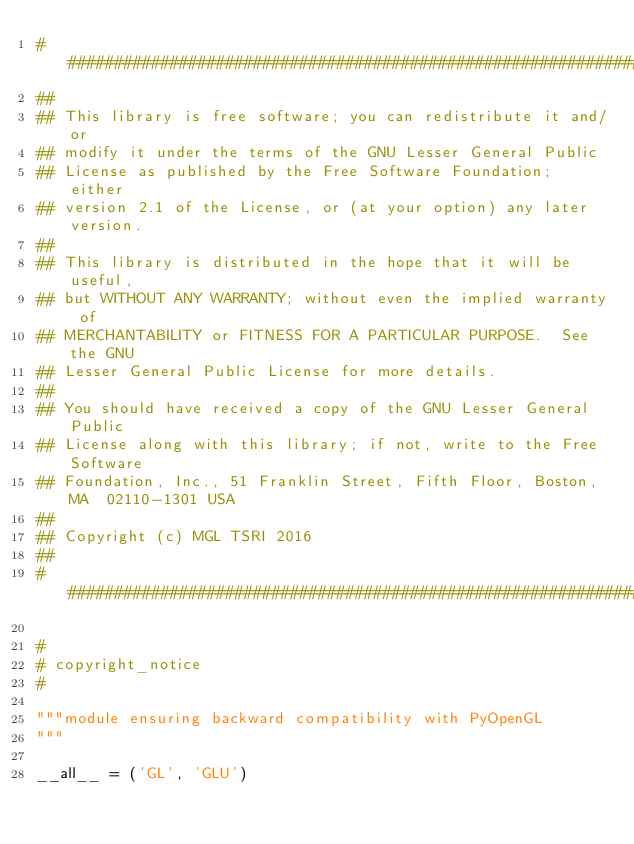Convert code to text. <code><loc_0><loc_0><loc_500><loc_500><_Python_>################################################################################
##
## This library is free software; you can redistribute it and/or
## modify it under the terms of the GNU Lesser General Public
## License as published by the Free Software Foundation; either
## version 2.1 of the License, or (at your option) any later version.
## 
## This library is distributed in the hope that it will be useful,
## but WITHOUT ANY WARRANTY; without even the implied warranty of
## MERCHANTABILITY or FITNESS FOR A PARTICULAR PURPOSE.  See the GNU
## Lesser General Public License for more details.
## 
## You should have received a copy of the GNU Lesser General Public
## License along with this library; if not, write to the Free Software
## Foundation, Inc., 51 Franklin Street, Fifth Floor, Boston, MA  02110-1301 USA
##
## Copyright (c) MGL TSRI 2016
##
################################################################################

#
# copyright_notice
#

"""module ensuring backward compatibility with PyOpenGL
"""

__all__ = ('GL', 'GLU')
</code> 